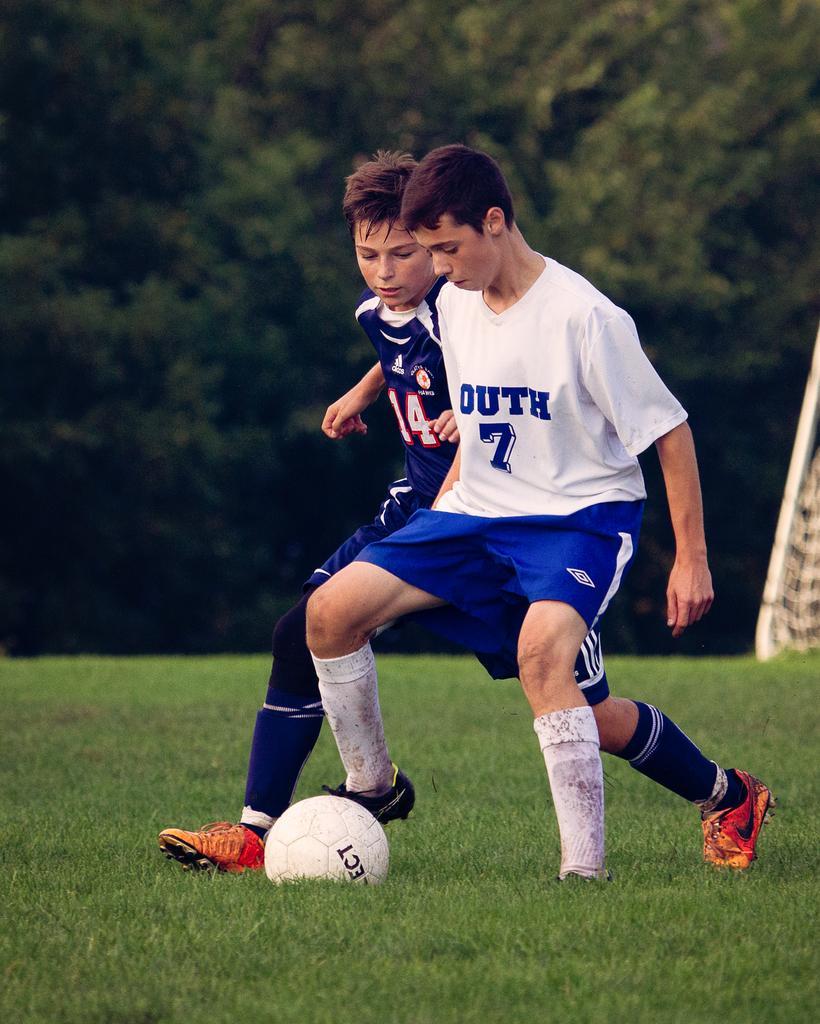Please provide a concise description of this image. In the image we can see there are kids standing on the ground and there is foot ball on the ground. The ground is covered with grass and behind there are trees. The image is little blurry at the back. 